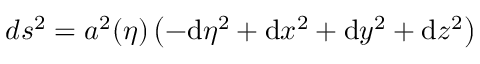<formula> <loc_0><loc_0><loc_500><loc_500>d s ^ { 2 } = a ^ { 2 } ( \eta ) \left ( - d \eta ^ { 2 } + d x ^ { 2 } + d y ^ { 2 } + d z ^ { 2 } \right )</formula> 